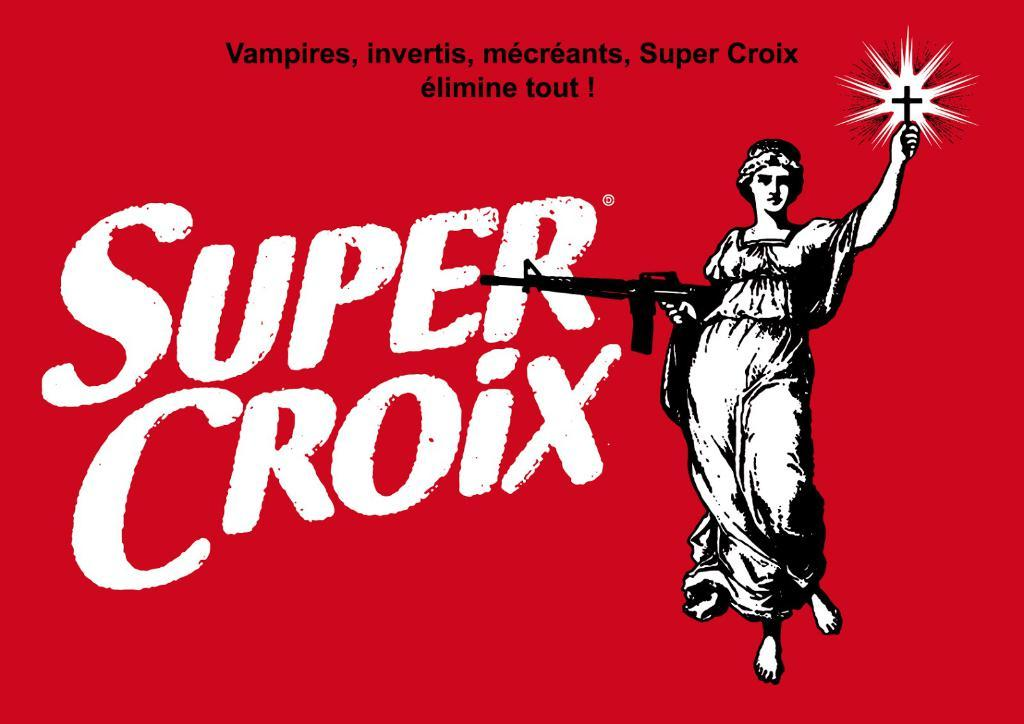<image>
Share a concise interpretation of the image provided. A red and white image of super croix with a woman holding a gun and a cross. 